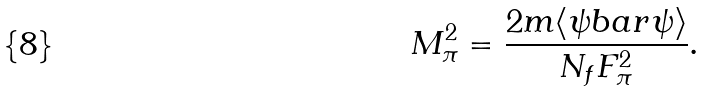<formula> <loc_0><loc_0><loc_500><loc_500>M _ { \pi } ^ { 2 } = \frac { 2 m \langle \psi b a r \psi \rangle } { N _ { f } F _ { \pi } ^ { 2 } } .</formula> 